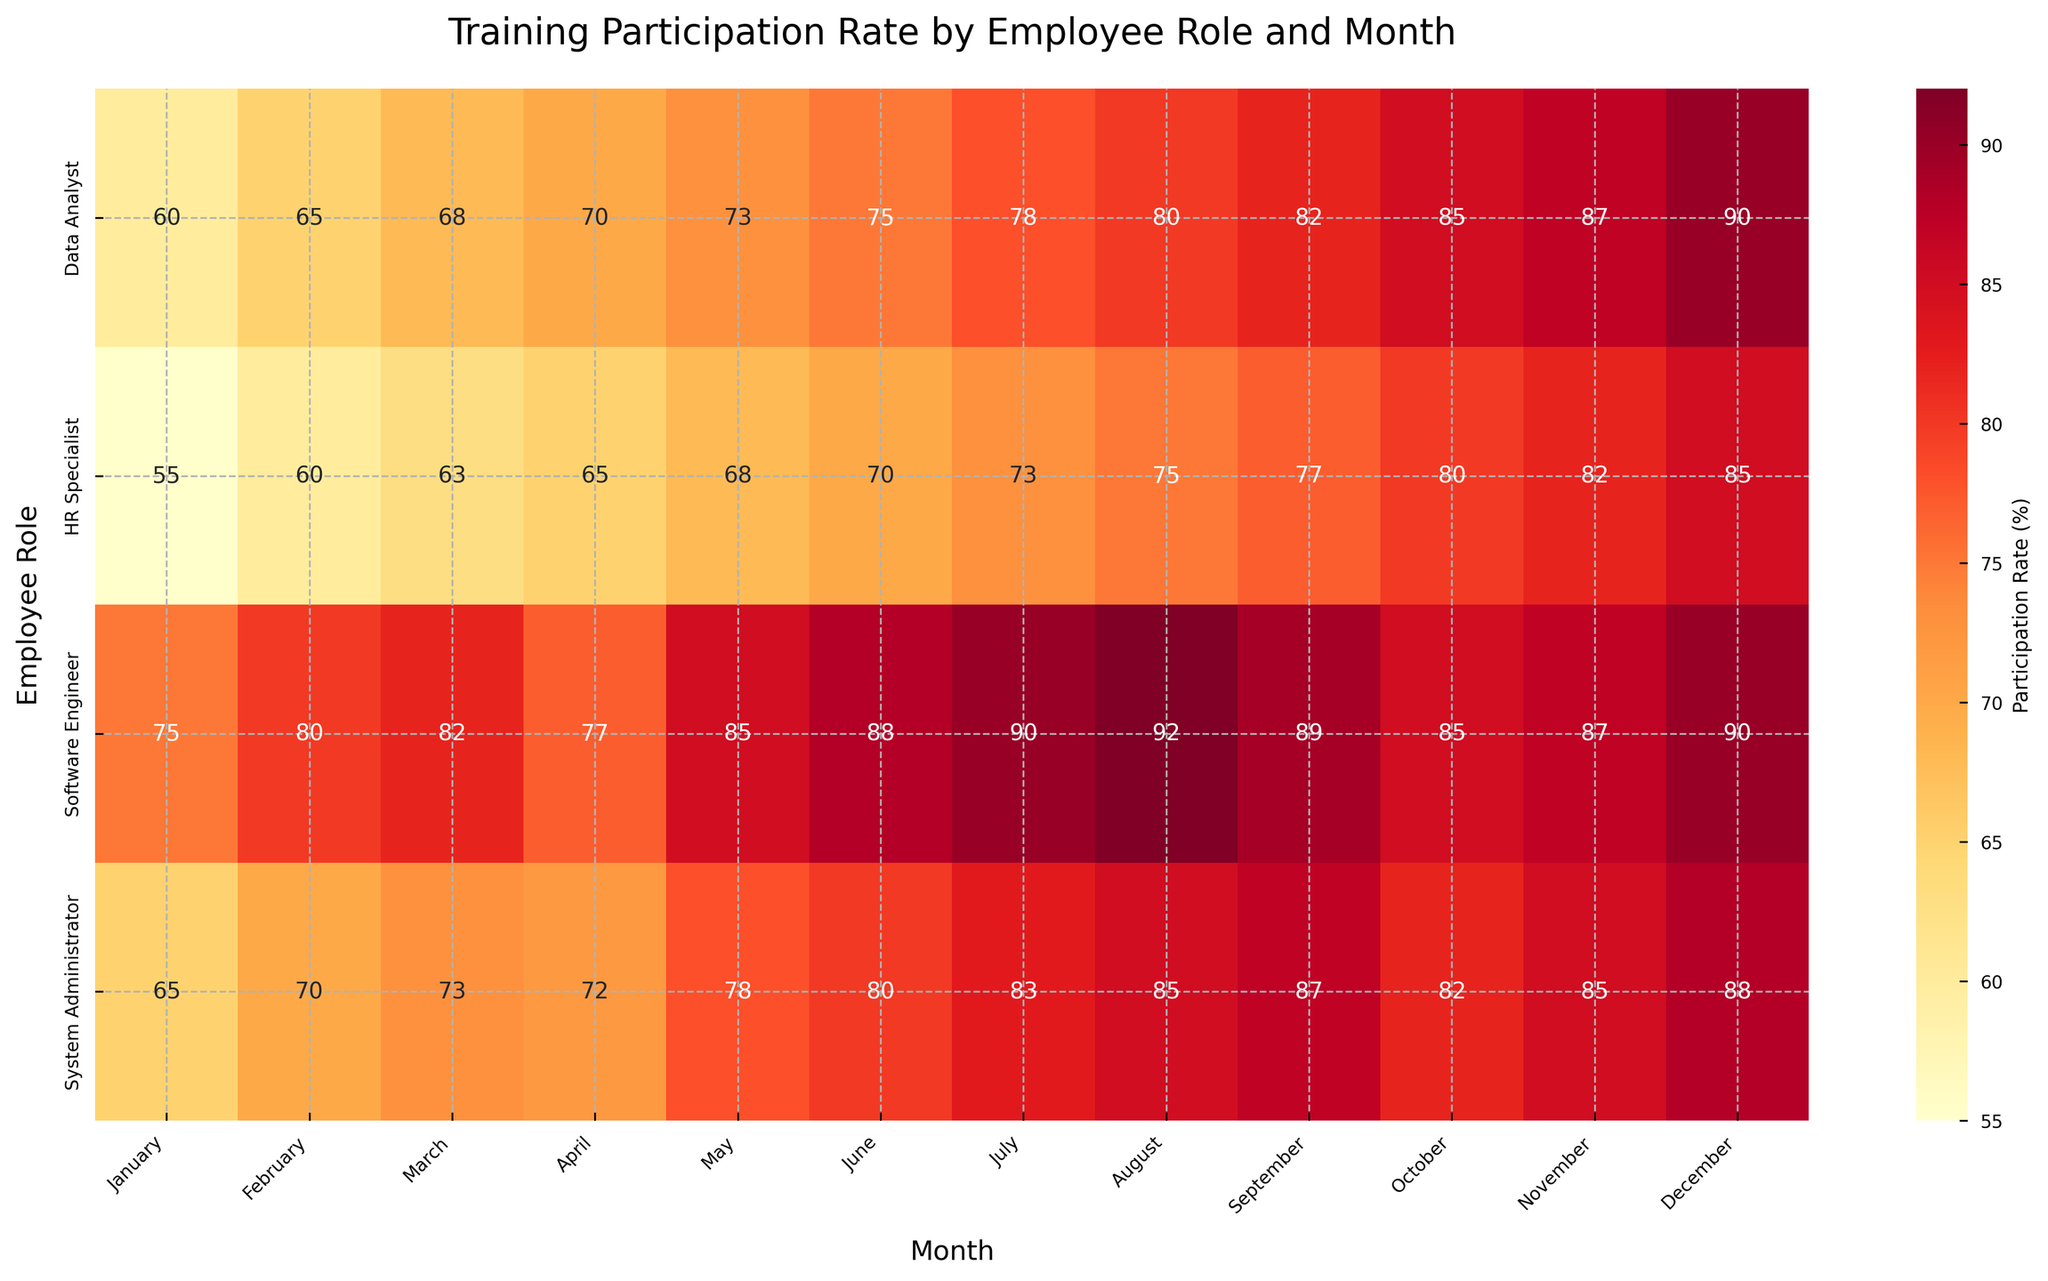What is the title of the heatmap? The title is usually at the top of the heatmap. For this figure, it states the main idea of the data being visualized.
Answer: Training Participation Rate by Employee Role and Month Which month shows the highest participation rate for Software Engineers? Look at the x-axis for months and track the values in the row for Software Engineers. The cell with the highest value indicates the month.
Answer: August How does the participation rate in December compare between Data Analysts and HR Specialists? Compare the values in the December column between Data Analysts and HR Specialists.
Answer: Data Analysts have a higher rate What is the mean participation rate for System Administrators from January to December? Sum the participation rates for all months for System Administrators and divide by 12 (total months).
Answer: 78.33% Which employee role had the lowest participation rate in January? Scan through the January column to find the lowest value, then look at the corresponding row for the employee role.
Answer: HR Specialist How does the participation rate trend for Data Analysts from January to December? Examine the cells in the row for Data Analysts from January to December to identify the trend.
Answer: Increasing trend Which employee role shows the least variation in participation rates throughout the year? Compare the change in participation rates across months for each role. The role with the smallest difference between highest and lowest values has the least variation.
Answer: Software Engineer What is the difference in participation rates between July and August for HR Specialists? Find and subtract the participation rates for July and August for HR Specialists.
Answer: 2% In which month do System Administrators have the same participation rate as December for Data Analysts? Identify the participation rate for Data Analysts in December, then find the month where System Administrators have the same value.
Answer: October and November What is the average participation rate for all roles in July? Sum the participation rates for all roles in July and divide by the number of different roles (4).
Answer: 81% 